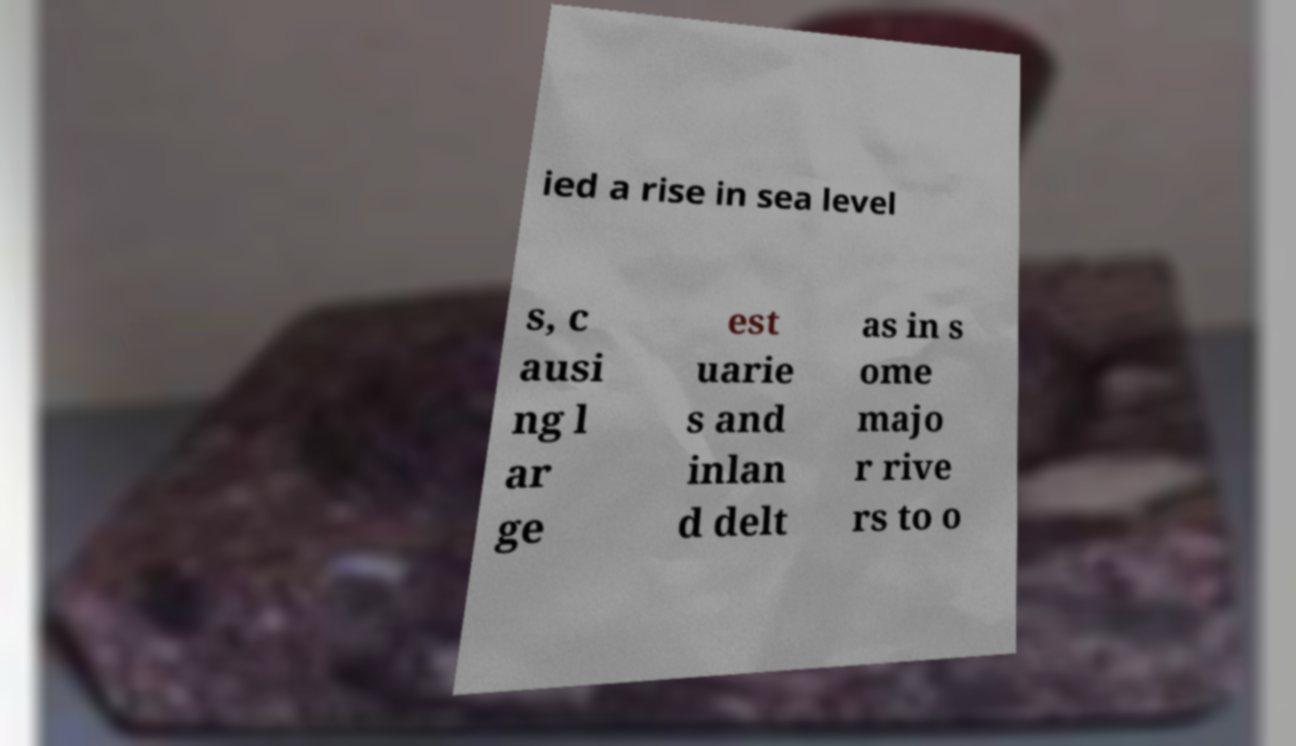Please read and relay the text visible in this image. What does it say? ied a rise in sea level s, c ausi ng l ar ge est uarie s and inlan d delt as in s ome majo r rive rs to o 